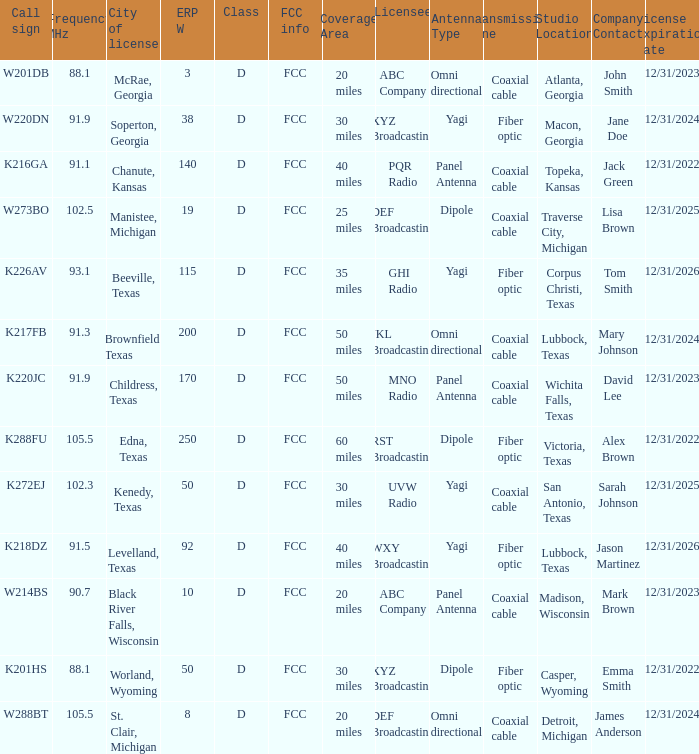What is City of License, when Frequency MHz is less than 102.5? McRae, Georgia, Soperton, Georgia, Chanute, Kansas, Beeville, Texas, Brownfield, Texas, Childress, Texas, Kenedy, Texas, Levelland, Texas, Black River Falls, Wisconsin, Worland, Wyoming. 